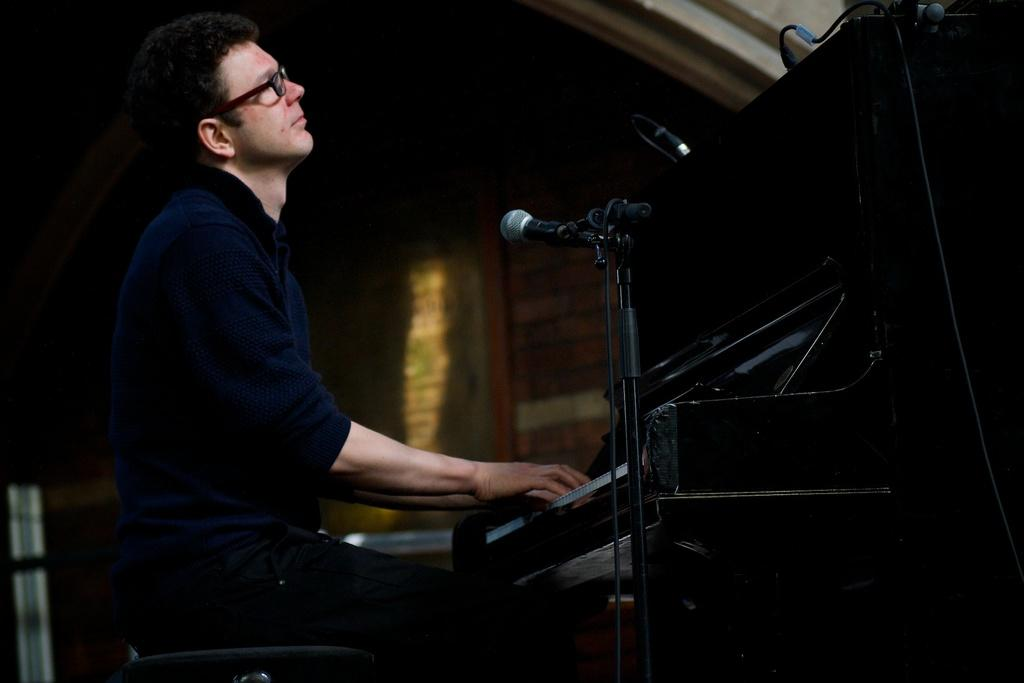What is the person in the image doing? The person is sitting and playing a musical instrument. What object is beside the person? There is a microphone beside the person. What type of sleet can be seen falling in the image? There is no sleet present in the image; it is an indoor setting with a person playing a musical instrument and a microphone beside them. What kind of magic is being performed in the image? There is no magic or illusion present in the image. 